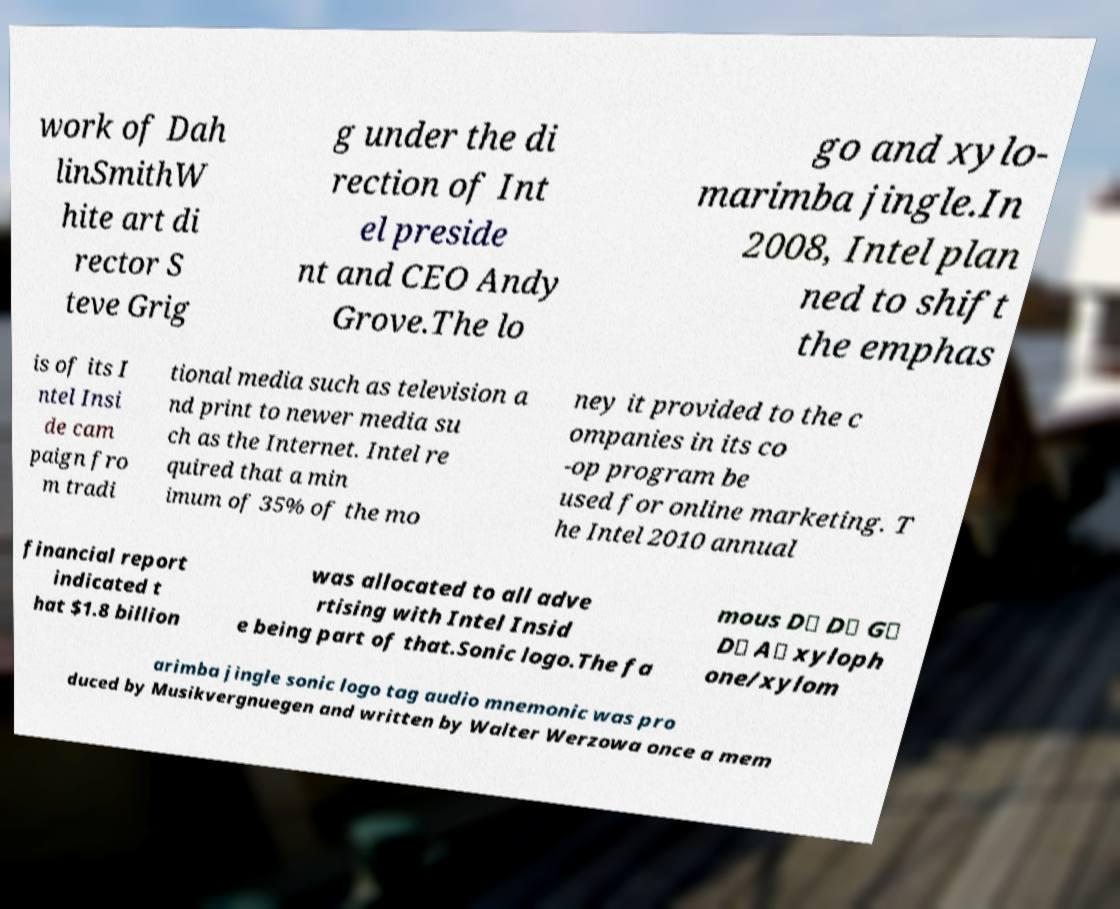Can you read and provide the text displayed in the image?This photo seems to have some interesting text. Can you extract and type it out for me? work of Dah linSmithW hite art di rector S teve Grig g under the di rection of Int el preside nt and CEO Andy Grove.The lo go and xylo- marimba jingle.In 2008, Intel plan ned to shift the emphas is of its I ntel Insi de cam paign fro m tradi tional media such as television a nd print to newer media su ch as the Internet. Intel re quired that a min imum of 35% of the mo ney it provided to the c ompanies in its co -op program be used for online marketing. T he Intel 2010 annual financial report indicated t hat $1.8 billion was allocated to all adve rtising with Intel Insid e being part of that.Sonic logo.The fa mous D♭ D♭ G♭ D♭ A♭ xyloph one/xylom arimba jingle sonic logo tag audio mnemonic was pro duced by Musikvergnuegen and written by Walter Werzowa once a mem 